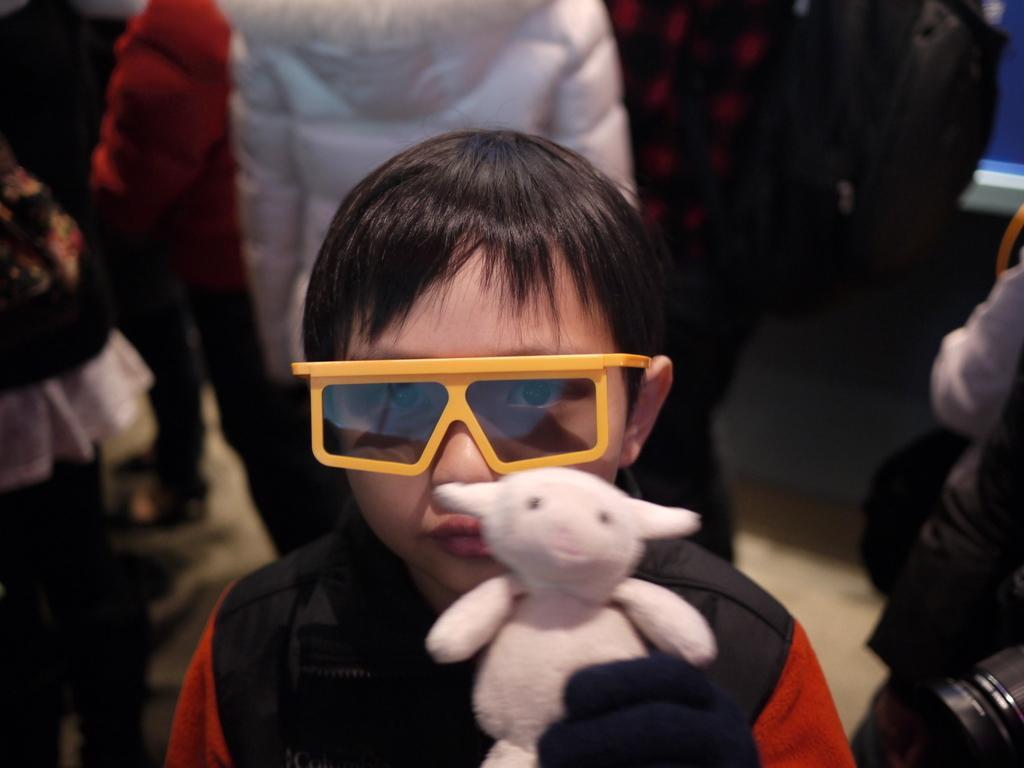Could you give a brief overview of what you see in this image? In this picture we can see a boy wearing goggles and holding a toy. In the background we can the partial part of the people. 